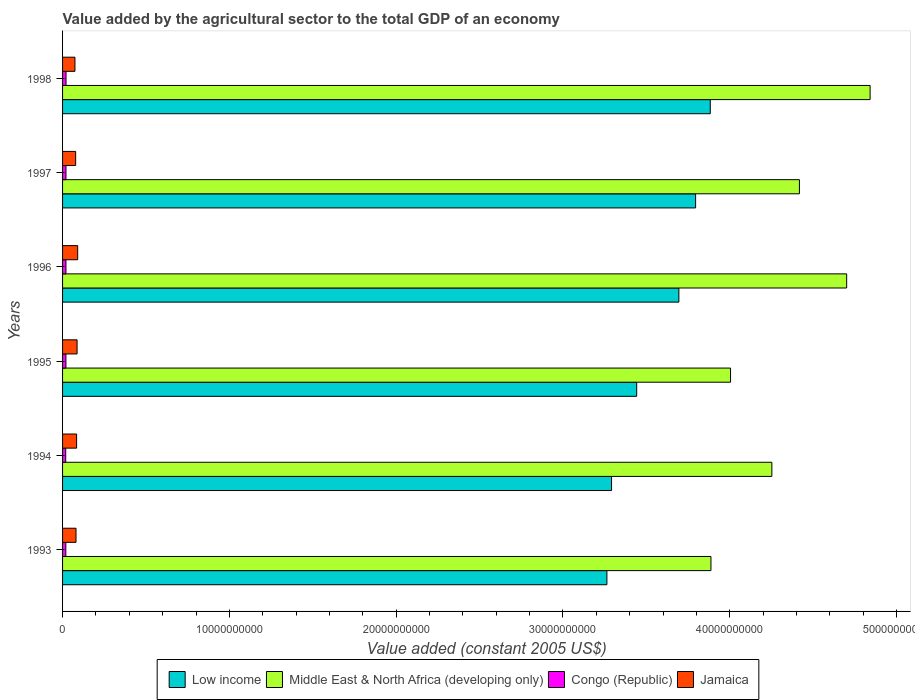How many groups of bars are there?
Ensure brevity in your answer.  6. How many bars are there on the 6th tick from the top?
Ensure brevity in your answer.  4. How many bars are there on the 4th tick from the bottom?
Make the answer very short. 4. What is the label of the 4th group of bars from the top?
Give a very brief answer. 1995. In how many cases, is the number of bars for a given year not equal to the number of legend labels?
Your response must be concise. 0. What is the value added by the agricultural sector in Low income in 1998?
Offer a terse response. 3.88e+1. Across all years, what is the maximum value added by the agricultural sector in Low income?
Provide a succinct answer. 3.88e+1. Across all years, what is the minimum value added by the agricultural sector in Jamaica?
Offer a very short reply. 7.42e+08. In which year was the value added by the agricultural sector in Middle East & North Africa (developing only) minimum?
Keep it short and to the point. 1993. What is the total value added by the agricultural sector in Congo (Republic) in the graph?
Provide a short and direct response. 1.20e+09. What is the difference between the value added by the agricultural sector in Jamaica in 1993 and that in 1994?
Offer a very short reply. -3.60e+07. What is the difference between the value added by the agricultural sector in Low income in 1998 and the value added by the agricultural sector in Congo (Republic) in 1997?
Keep it short and to the point. 3.86e+1. What is the average value added by the agricultural sector in Middle East & North Africa (developing only) per year?
Keep it short and to the point. 4.35e+1. In the year 1996, what is the difference between the value added by the agricultural sector in Low income and value added by the agricultural sector in Jamaica?
Your answer should be very brief. 3.60e+1. What is the ratio of the value added by the agricultural sector in Low income in 1997 to that in 1998?
Offer a very short reply. 0.98. Is the value added by the agricultural sector in Congo (Republic) in 1994 less than that in 1995?
Provide a short and direct response. Yes. Is the difference between the value added by the agricultural sector in Low income in 1993 and 1995 greater than the difference between the value added by the agricultural sector in Jamaica in 1993 and 1995?
Your response must be concise. No. What is the difference between the highest and the second highest value added by the agricultural sector in Congo (Republic)?
Give a very brief answer. 3.44e+06. What is the difference between the highest and the lowest value added by the agricultural sector in Middle East & North Africa (developing only)?
Provide a succinct answer. 9.54e+09. Is it the case that in every year, the sum of the value added by the agricultural sector in Congo (Republic) and value added by the agricultural sector in Jamaica is greater than the sum of value added by the agricultural sector in Middle East & North Africa (developing only) and value added by the agricultural sector in Low income?
Ensure brevity in your answer.  No. What does the 2nd bar from the top in 1995 represents?
Your answer should be very brief. Congo (Republic). What does the 4th bar from the bottom in 1996 represents?
Your answer should be very brief. Jamaica. How many bars are there?
Your response must be concise. 24. Are all the bars in the graph horizontal?
Offer a terse response. Yes. Where does the legend appear in the graph?
Your answer should be very brief. Bottom center. How are the legend labels stacked?
Your answer should be compact. Horizontal. What is the title of the graph?
Your answer should be very brief. Value added by the agricultural sector to the total GDP of an economy. Does "Guyana" appear as one of the legend labels in the graph?
Your answer should be very brief. No. What is the label or title of the X-axis?
Provide a succinct answer. Value added (constant 2005 US$). What is the Value added (constant 2005 US$) in Low income in 1993?
Your response must be concise. 3.26e+1. What is the Value added (constant 2005 US$) of Middle East & North Africa (developing only) in 1993?
Ensure brevity in your answer.  3.89e+1. What is the Value added (constant 2005 US$) of Congo (Republic) in 1993?
Keep it short and to the point. 1.96e+08. What is the Value added (constant 2005 US$) in Jamaica in 1993?
Your answer should be compact. 8.06e+08. What is the Value added (constant 2005 US$) in Low income in 1994?
Ensure brevity in your answer.  3.29e+1. What is the Value added (constant 2005 US$) in Middle East & North Africa (developing only) in 1994?
Your answer should be compact. 4.25e+1. What is the Value added (constant 2005 US$) of Congo (Republic) in 1994?
Your answer should be compact. 1.89e+08. What is the Value added (constant 2005 US$) in Jamaica in 1994?
Offer a very short reply. 8.42e+08. What is the Value added (constant 2005 US$) of Low income in 1995?
Make the answer very short. 3.44e+1. What is the Value added (constant 2005 US$) in Middle East & North Africa (developing only) in 1995?
Provide a short and direct response. 4.00e+1. What is the Value added (constant 2005 US$) in Congo (Republic) in 1995?
Keep it short and to the point. 2.02e+08. What is the Value added (constant 2005 US$) of Jamaica in 1995?
Your answer should be very brief. 8.70e+08. What is the Value added (constant 2005 US$) of Low income in 1996?
Give a very brief answer. 3.70e+1. What is the Value added (constant 2005 US$) in Middle East & North Africa (developing only) in 1996?
Give a very brief answer. 4.70e+1. What is the Value added (constant 2005 US$) in Congo (Republic) in 1996?
Ensure brevity in your answer.  2.03e+08. What is the Value added (constant 2005 US$) of Jamaica in 1996?
Make the answer very short. 9.05e+08. What is the Value added (constant 2005 US$) in Low income in 1997?
Make the answer very short. 3.80e+1. What is the Value added (constant 2005 US$) of Middle East & North Africa (developing only) in 1997?
Give a very brief answer. 4.42e+1. What is the Value added (constant 2005 US$) of Congo (Republic) in 1997?
Offer a terse response. 2.04e+08. What is the Value added (constant 2005 US$) of Jamaica in 1997?
Your response must be concise. 7.84e+08. What is the Value added (constant 2005 US$) in Low income in 1998?
Make the answer very short. 3.88e+1. What is the Value added (constant 2005 US$) in Middle East & North Africa (developing only) in 1998?
Your response must be concise. 4.84e+1. What is the Value added (constant 2005 US$) of Congo (Republic) in 1998?
Make the answer very short. 2.08e+08. What is the Value added (constant 2005 US$) in Jamaica in 1998?
Provide a succinct answer. 7.42e+08. Across all years, what is the maximum Value added (constant 2005 US$) of Low income?
Make the answer very short. 3.88e+1. Across all years, what is the maximum Value added (constant 2005 US$) in Middle East & North Africa (developing only)?
Your answer should be compact. 4.84e+1. Across all years, what is the maximum Value added (constant 2005 US$) in Congo (Republic)?
Ensure brevity in your answer.  2.08e+08. Across all years, what is the maximum Value added (constant 2005 US$) in Jamaica?
Provide a succinct answer. 9.05e+08. Across all years, what is the minimum Value added (constant 2005 US$) of Low income?
Your response must be concise. 3.26e+1. Across all years, what is the minimum Value added (constant 2005 US$) of Middle East & North Africa (developing only)?
Your response must be concise. 3.89e+1. Across all years, what is the minimum Value added (constant 2005 US$) of Congo (Republic)?
Ensure brevity in your answer.  1.89e+08. Across all years, what is the minimum Value added (constant 2005 US$) in Jamaica?
Give a very brief answer. 7.42e+08. What is the total Value added (constant 2005 US$) in Low income in the graph?
Your answer should be compact. 2.14e+11. What is the total Value added (constant 2005 US$) of Middle East & North Africa (developing only) in the graph?
Your response must be concise. 2.61e+11. What is the total Value added (constant 2005 US$) of Congo (Republic) in the graph?
Offer a terse response. 1.20e+09. What is the total Value added (constant 2005 US$) of Jamaica in the graph?
Your response must be concise. 4.95e+09. What is the difference between the Value added (constant 2005 US$) of Low income in 1993 and that in 1994?
Offer a terse response. -2.78e+08. What is the difference between the Value added (constant 2005 US$) of Middle East & North Africa (developing only) in 1993 and that in 1994?
Provide a short and direct response. -3.65e+09. What is the difference between the Value added (constant 2005 US$) in Congo (Republic) in 1993 and that in 1994?
Keep it short and to the point. 6.23e+06. What is the difference between the Value added (constant 2005 US$) in Jamaica in 1993 and that in 1994?
Give a very brief answer. -3.60e+07. What is the difference between the Value added (constant 2005 US$) in Low income in 1993 and that in 1995?
Your answer should be compact. -1.79e+09. What is the difference between the Value added (constant 2005 US$) in Middle East & North Africa (developing only) in 1993 and that in 1995?
Give a very brief answer. -1.17e+09. What is the difference between the Value added (constant 2005 US$) in Congo (Republic) in 1993 and that in 1995?
Offer a very short reply. -6.02e+06. What is the difference between the Value added (constant 2005 US$) in Jamaica in 1993 and that in 1995?
Offer a terse response. -6.43e+07. What is the difference between the Value added (constant 2005 US$) of Low income in 1993 and that in 1996?
Offer a very short reply. -4.31e+09. What is the difference between the Value added (constant 2005 US$) of Middle East & North Africa (developing only) in 1993 and that in 1996?
Give a very brief answer. -8.14e+09. What is the difference between the Value added (constant 2005 US$) of Congo (Republic) in 1993 and that in 1996?
Your answer should be very brief. -7.11e+06. What is the difference between the Value added (constant 2005 US$) in Jamaica in 1993 and that in 1996?
Offer a very short reply. -9.91e+07. What is the difference between the Value added (constant 2005 US$) of Low income in 1993 and that in 1997?
Offer a very short reply. -5.32e+09. What is the difference between the Value added (constant 2005 US$) of Middle East & North Africa (developing only) in 1993 and that in 1997?
Ensure brevity in your answer.  -5.30e+09. What is the difference between the Value added (constant 2005 US$) in Congo (Republic) in 1993 and that in 1997?
Your answer should be compact. -8.71e+06. What is the difference between the Value added (constant 2005 US$) in Jamaica in 1993 and that in 1997?
Ensure brevity in your answer.  2.17e+07. What is the difference between the Value added (constant 2005 US$) of Low income in 1993 and that in 1998?
Offer a very short reply. -6.20e+09. What is the difference between the Value added (constant 2005 US$) of Middle East & North Africa (developing only) in 1993 and that in 1998?
Your answer should be compact. -9.54e+09. What is the difference between the Value added (constant 2005 US$) in Congo (Republic) in 1993 and that in 1998?
Offer a very short reply. -1.22e+07. What is the difference between the Value added (constant 2005 US$) in Jamaica in 1993 and that in 1998?
Your answer should be compact. 6.37e+07. What is the difference between the Value added (constant 2005 US$) of Low income in 1994 and that in 1995?
Your answer should be very brief. -1.51e+09. What is the difference between the Value added (constant 2005 US$) of Middle East & North Africa (developing only) in 1994 and that in 1995?
Provide a succinct answer. 2.48e+09. What is the difference between the Value added (constant 2005 US$) of Congo (Republic) in 1994 and that in 1995?
Ensure brevity in your answer.  -1.23e+07. What is the difference between the Value added (constant 2005 US$) in Jamaica in 1994 and that in 1995?
Offer a very short reply. -2.83e+07. What is the difference between the Value added (constant 2005 US$) of Low income in 1994 and that in 1996?
Your response must be concise. -4.04e+09. What is the difference between the Value added (constant 2005 US$) of Middle East & North Africa (developing only) in 1994 and that in 1996?
Make the answer very short. -4.48e+09. What is the difference between the Value added (constant 2005 US$) in Congo (Republic) in 1994 and that in 1996?
Ensure brevity in your answer.  -1.33e+07. What is the difference between the Value added (constant 2005 US$) in Jamaica in 1994 and that in 1996?
Give a very brief answer. -6.31e+07. What is the difference between the Value added (constant 2005 US$) of Low income in 1994 and that in 1997?
Keep it short and to the point. -5.04e+09. What is the difference between the Value added (constant 2005 US$) of Middle East & North Africa (developing only) in 1994 and that in 1997?
Offer a terse response. -1.65e+09. What is the difference between the Value added (constant 2005 US$) in Congo (Republic) in 1994 and that in 1997?
Provide a succinct answer. -1.49e+07. What is the difference between the Value added (constant 2005 US$) in Jamaica in 1994 and that in 1997?
Provide a short and direct response. 5.77e+07. What is the difference between the Value added (constant 2005 US$) in Low income in 1994 and that in 1998?
Ensure brevity in your answer.  -5.92e+09. What is the difference between the Value added (constant 2005 US$) of Middle East & North Africa (developing only) in 1994 and that in 1998?
Offer a terse response. -5.89e+09. What is the difference between the Value added (constant 2005 US$) in Congo (Republic) in 1994 and that in 1998?
Give a very brief answer. -1.84e+07. What is the difference between the Value added (constant 2005 US$) of Jamaica in 1994 and that in 1998?
Provide a short and direct response. 9.97e+07. What is the difference between the Value added (constant 2005 US$) of Low income in 1995 and that in 1996?
Keep it short and to the point. -2.53e+09. What is the difference between the Value added (constant 2005 US$) of Middle East & North Africa (developing only) in 1995 and that in 1996?
Make the answer very short. -6.96e+09. What is the difference between the Value added (constant 2005 US$) in Congo (Republic) in 1995 and that in 1996?
Your response must be concise. -1.09e+06. What is the difference between the Value added (constant 2005 US$) in Jamaica in 1995 and that in 1996?
Give a very brief answer. -3.49e+07. What is the difference between the Value added (constant 2005 US$) in Low income in 1995 and that in 1997?
Offer a very short reply. -3.53e+09. What is the difference between the Value added (constant 2005 US$) in Middle East & North Africa (developing only) in 1995 and that in 1997?
Your answer should be very brief. -4.13e+09. What is the difference between the Value added (constant 2005 US$) of Congo (Republic) in 1995 and that in 1997?
Ensure brevity in your answer.  -2.69e+06. What is the difference between the Value added (constant 2005 US$) in Jamaica in 1995 and that in 1997?
Your response must be concise. 8.59e+07. What is the difference between the Value added (constant 2005 US$) of Low income in 1995 and that in 1998?
Your answer should be compact. -4.41e+09. What is the difference between the Value added (constant 2005 US$) of Middle East & North Africa (developing only) in 1995 and that in 1998?
Your answer should be compact. -8.37e+09. What is the difference between the Value added (constant 2005 US$) of Congo (Republic) in 1995 and that in 1998?
Ensure brevity in your answer.  -6.13e+06. What is the difference between the Value added (constant 2005 US$) in Jamaica in 1995 and that in 1998?
Keep it short and to the point. 1.28e+08. What is the difference between the Value added (constant 2005 US$) in Low income in 1996 and that in 1997?
Keep it short and to the point. -1.00e+09. What is the difference between the Value added (constant 2005 US$) in Middle East & North Africa (developing only) in 1996 and that in 1997?
Your answer should be very brief. 2.83e+09. What is the difference between the Value added (constant 2005 US$) in Congo (Republic) in 1996 and that in 1997?
Your answer should be compact. -1.60e+06. What is the difference between the Value added (constant 2005 US$) in Jamaica in 1996 and that in 1997?
Provide a succinct answer. 1.21e+08. What is the difference between the Value added (constant 2005 US$) of Low income in 1996 and that in 1998?
Provide a succinct answer. -1.88e+09. What is the difference between the Value added (constant 2005 US$) in Middle East & North Africa (developing only) in 1996 and that in 1998?
Make the answer very short. -1.41e+09. What is the difference between the Value added (constant 2005 US$) of Congo (Republic) in 1996 and that in 1998?
Provide a short and direct response. -5.04e+06. What is the difference between the Value added (constant 2005 US$) in Jamaica in 1996 and that in 1998?
Offer a terse response. 1.63e+08. What is the difference between the Value added (constant 2005 US$) in Low income in 1997 and that in 1998?
Your answer should be compact. -8.79e+08. What is the difference between the Value added (constant 2005 US$) of Middle East & North Africa (developing only) in 1997 and that in 1998?
Your answer should be compact. -4.24e+09. What is the difference between the Value added (constant 2005 US$) of Congo (Republic) in 1997 and that in 1998?
Ensure brevity in your answer.  -3.44e+06. What is the difference between the Value added (constant 2005 US$) in Jamaica in 1997 and that in 1998?
Offer a very short reply. 4.20e+07. What is the difference between the Value added (constant 2005 US$) in Low income in 1993 and the Value added (constant 2005 US$) in Middle East & North Africa (developing only) in 1994?
Give a very brief answer. -9.89e+09. What is the difference between the Value added (constant 2005 US$) in Low income in 1993 and the Value added (constant 2005 US$) in Congo (Republic) in 1994?
Offer a terse response. 3.24e+1. What is the difference between the Value added (constant 2005 US$) of Low income in 1993 and the Value added (constant 2005 US$) of Jamaica in 1994?
Offer a very short reply. 3.18e+1. What is the difference between the Value added (constant 2005 US$) in Middle East & North Africa (developing only) in 1993 and the Value added (constant 2005 US$) in Congo (Republic) in 1994?
Your answer should be very brief. 3.87e+1. What is the difference between the Value added (constant 2005 US$) in Middle East & North Africa (developing only) in 1993 and the Value added (constant 2005 US$) in Jamaica in 1994?
Offer a terse response. 3.80e+1. What is the difference between the Value added (constant 2005 US$) of Congo (Republic) in 1993 and the Value added (constant 2005 US$) of Jamaica in 1994?
Provide a succinct answer. -6.46e+08. What is the difference between the Value added (constant 2005 US$) in Low income in 1993 and the Value added (constant 2005 US$) in Middle East & North Africa (developing only) in 1995?
Offer a terse response. -7.41e+09. What is the difference between the Value added (constant 2005 US$) of Low income in 1993 and the Value added (constant 2005 US$) of Congo (Republic) in 1995?
Offer a very short reply. 3.24e+1. What is the difference between the Value added (constant 2005 US$) in Low income in 1993 and the Value added (constant 2005 US$) in Jamaica in 1995?
Provide a short and direct response. 3.18e+1. What is the difference between the Value added (constant 2005 US$) in Middle East & North Africa (developing only) in 1993 and the Value added (constant 2005 US$) in Congo (Republic) in 1995?
Provide a short and direct response. 3.87e+1. What is the difference between the Value added (constant 2005 US$) of Middle East & North Africa (developing only) in 1993 and the Value added (constant 2005 US$) of Jamaica in 1995?
Offer a very short reply. 3.80e+1. What is the difference between the Value added (constant 2005 US$) of Congo (Republic) in 1993 and the Value added (constant 2005 US$) of Jamaica in 1995?
Offer a very short reply. -6.75e+08. What is the difference between the Value added (constant 2005 US$) in Low income in 1993 and the Value added (constant 2005 US$) in Middle East & North Africa (developing only) in 1996?
Keep it short and to the point. -1.44e+1. What is the difference between the Value added (constant 2005 US$) in Low income in 1993 and the Value added (constant 2005 US$) in Congo (Republic) in 1996?
Offer a very short reply. 3.24e+1. What is the difference between the Value added (constant 2005 US$) in Low income in 1993 and the Value added (constant 2005 US$) in Jamaica in 1996?
Offer a terse response. 3.17e+1. What is the difference between the Value added (constant 2005 US$) of Middle East & North Africa (developing only) in 1993 and the Value added (constant 2005 US$) of Congo (Republic) in 1996?
Your answer should be compact. 3.87e+1. What is the difference between the Value added (constant 2005 US$) in Middle East & North Africa (developing only) in 1993 and the Value added (constant 2005 US$) in Jamaica in 1996?
Keep it short and to the point. 3.80e+1. What is the difference between the Value added (constant 2005 US$) of Congo (Republic) in 1993 and the Value added (constant 2005 US$) of Jamaica in 1996?
Make the answer very short. -7.10e+08. What is the difference between the Value added (constant 2005 US$) of Low income in 1993 and the Value added (constant 2005 US$) of Middle East & North Africa (developing only) in 1997?
Offer a very short reply. -1.15e+1. What is the difference between the Value added (constant 2005 US$) in Low income in 1993 and the Value added (constant 2005 US$) in Congo (Republic) in 1997?
Offer a terse response. 3.24e+1. What is the difference between the Value added (constant 2005 US$) of Low income in 1993 and the Value added (constant 2005 US$) of Jamaica in 1997?
Give a very brief answer. 3.19e+1. What is the difference between the Value added (constant 2005 US$) in Middle East & North Africa (developing only) in 1993 and the Value added (constant 2005 US$) in Congo (Republic) in 1997?
Ensure brevity in your answer.  3.87e+1. What is the difference between the Value added (constant 2005 US$) in Middle East & North Africa (developing only) in 1993 and the Value added (constant 2005 US$) in Jamaica in 1997?
Your response must be concise. 3.81e+1. What is the difference between the Value added (constant 2005 US$) in Congo (Republic) in 1993 and the Value added (constant 2005 US$) in Jamaica in 1997?
Your answer should be compact. -5.89e+08. What is the difference between the Value added (constant 2005 US$) of Low income in 1993 and the Value added (constant 2005 US$) of Middle East & North Africa (developing only) in 1998?
Offer a very short reply. -1.58e+1. What is the difference between the Value added (constant 2005 US$) in Low income in 1993 and the Value added (constant 2005 US$) in Congo (Republic) in 1998?
Keep it short and to the point. 3.24e+1. What is the difference between the Value added (constant 2005 US$) of Low income in 1993 and the Value added (constant 2005 US$) of Jamaica in 1998?
Your answer should be compact. 3.19e+1. What is the difference between the Value added (constant 2005 US$) in Middle East & North Africa (developing only) in 1993 and the Value added (constant 2005 US$) in Congo (Republic) in 1998?
Your answer should be compact. 3.87e+1. What is the difference between the Value added (constant 2005 US$) in Middle East & North Africa (developing only) in 1993 and the Value added (constant 2005 US$) in Jamaica in 1998?
Give a very brief answer. 3.81e+1. What is the difference between the Value added (constant 2005 US$) in Congo (Republic) in 1993 and the Value added (constant 2005 US$) in Jamaica in 1998?
Ensure brevity in your answer.  -5.47e+08. What is the difference between the Value added (constant 2005 US$) in Low income in 1994 and the Value added (constant 2005 US$) in Middle East & North Africa (developing only) in 1995?
Offer a terse response. -7.13e+09. What is the difference between the Value added (constant 2005 US$) of Low income in 1994 and the Value added (constant 2005 US$) of Congo (Republic) in 1995?
Provide a succinct answer. 3.27e+1. What is the difference between the Value added (constant 2005 US$) in Low income in 1994 and the Value added (constant 2005 US$) in Jamaica in 1995?
Keep it short and to the point. 3.20e+1. What is the difference between the Value added (constant 2005 US$) in Middle East & North Africa (developing only) in 1994 and the Value added (constant 2005 US$) in Congo (Republic) in 1995?
Give a very brief answer. 4.23e+1. What is the difference between the Value added (constant 2005 US$) in Middle East & North Africa (developing only) in 1994 and the Value added (constant 2005 US$) in Jamaica in 1995?
Make the answer very short. 4.17e+1. What is the difference between the Value added (constant 2005 US$) in Congo (Republic) in 1994 and the Value added (constant 2005 US$) in Jamaica in 1995?
Offer a terse response. -6.81e+08. What is the difference between the Value added (constant 2005 US$) of Low income in 1994 and the Value added (constant 2005 US$) of Middle East & North Africa (developing only) in 1996?
Provide a short and direct response. -1.41e+1. What is the difference between the Value added (constant 2005 US$) in Low income in 1994 and the Value added (constant 2005 US$) in Congo (Republic) in 1996?
Offer a very short reply. 3.27e+1. What is the difference between the Value added (constant 2005 US$) in Low income in 1994 and the Value added (constant 2005 US$) in Jamaica in 1996?
Keep it short and to the point. 3.20e+1. What is the difference between the Value added (constant 2005 US$) in Middle East & North Africa (developing only) in 1994 and the Value added (constant 2005 US$) in Congo (Republic) in 1996?
Ensure brevity in your answer.  4.23e+1. What is the difference between the Value added (constant 2005 US$) in Middle East & North Africa (developing only) in 1994 and the Value added (constant 2005 US$) in Jamaica in 1996?
Your answer should be very brief. 4.16e+1. What is the difference between the Value added (constant 2005 US$) of Congo (Republic) in 1994 and the Value added (constant 2005 US$) of Jamaica in 1996?
Provide a succinct answer. -7.16e+08. What is the difference between the Value added (constant 2005 US$) of Low income in 1994 and the Value added (constant 2005 US$) of Middle East & North Africa (developing only) in 1997?
Make the answer very short. -1.13e+1. What is the difference between the Value added (constant 2005 US$) of Low income in 1994 and the Value added (constant 2005 US$) of Congo (Republic) in 1997?
Offer a terse response. 3.27e+1. What is the difference between the Value added (constant 2005 US$) in Low income in 1994 and the Value added (constant 2005 US$) in Jamaica in 1997?
Your answer should be compact. 3.21e+1. What is the difference between the Value added (constant 2005 US$) of Middle East & North Africa (developing only) in 1994 and the Value added (constant 2005 US$) of Congo (Republic) in 1997?
Make the answer very short. 4.23e+1. What is the difference between the Value added (constant 2005 US$) of Middle East & North Africa (developing only) in 1994 and the Value added (constant 2005 US$) of Jamaica in 1997?
Provide a short and direct response. 4.17e+1. What is the difference between the Value added (constant 2005 US$) of Congo (Republic) in 1994 and the Value added (constant 2005 US$) of Jamaica in 1997?
Your answer should be compact. -5.95e+08. What is the difference between the Value added (constant 2005 US$) of Low income in 1994 and the Value added (constant 2005 US$) of Middle East & North Africa (developing only) in 1998?
Your answer should be compact. -1.55e+1. What is the difference between the Value added (constant 2005 US$) of Low income in 1994 and the Value added (constant 2005 US$) of Congo (Republic) in 1998?
Your response must be concise. 3.27e+1. What is the difference between the Value added (constant 2005 US$) in Low income in 1994 and the Value added (constant 2005 US$) in Jamaica in 1998?
Provide a short and direct response. 3.22e+1. What is the difference between the Value added (constant 2005 US$) in Middle East & North Africa (developing only) in 1994 and the Value added (constant 2005 US$) in Congo (Republic) in 1998?
Keep it short and to the point. 4.23e+1. What is the difference between the Value added (constant 2005 US$) in Middle East & North Africa (developing only) in 1994 and the Value added (constant 2005 US$) in Jamaica in 1998?
Your answer should be very brief. 4.18e+1. What is the difference between the Value added (constant 2005 US$) of Congo (Republic) in 1994 and the Value added (constant 2005 US$) of Jamaica in 1998?
Provide a short and direct response. -5.53e+08. What is the difference between the Value added (constant 2005 US$) in Low income in 1995 and the Value added (constant 2005 US$) in Middle East & North Africa (developing only) in 1996?
Make the answer very short. -1.26e+1. What is the difference between the Value added (constant 2005 US$) of Low income in 1995 and the Value added (constant 2005 US$) of Congo (Republic) in 1996?
Your response must be concise. 3.42e+1. What is the difference between the Value added (constant 2005 US$) in Low income in 1995 and the Value added (constant 2005 US$) in Jamaica in 1996?
Make the answer very short. 3.35e+1. What is the difference between the Value added (constant 2005 US$) of Middle East & North Africa (developing only) in 1995 and the Value added (constant 2005 US$) of Congo (Republic) in 1996?
Provide a succinct answer. 3.98e+1. What is the difference between the Value added (constant 2005 US$) of Middle East & North Africa (developing only) in 1995 and the Value added (constant 2005 US$) of Jamaica in 1996?
Make the answer very short. 3.91e+1. What is the difference between the Value added (constant 2005 US$) in Congo (Republic) in 1995 and the Value added (constant 2005 US$) in Jamaica in 1996?
Your response must be concise. -7.04e+08. What is the difference between the Value added (constant 2005 US$) of Low income in 1995 and the Value added (constant 2005 US$) of Middle East & North Africa (developing only) in 1997?
Provide a short and direct response. -9.76e+09. What is the difference between the Value added (constant 2005 US$) of Low income in 1995 and the Value added (constant 2005 US$) of Congo (Republic) in 1997?
Your response must be concise. 3.42e+1. What is the difference between the Value added (constant 2005 US$) in Low income in 1995 and the Value added (constant 2005 US$) in Jamaica in 1997?
Make the answer very short. 3.36e+1. What is the difference between the Value added (constant 2005 US$) of Middle East & North Africa (developing only) in 1995 and the Value added (constant 2005 US$) of Congo (Republic) in 1997?
Provide a succinct answer. 3.98e+1. What is the difference between the Value added (constant 2005 US$) of Middle East & North Africa (developing only) in 1995 and the Value added (constant 2005 US$) of Jamaica in 1997?
Offer a terse response. 3.93e+1. What is the difference between the Value added (constant 2005 US$) in Congo (Republic) in 1995 and the Value added (constant 2005 US$) in Jamaica in 1997?
Ensure brevity in your answer.  -5.83e+08. What is the difference between the Value added (constant 2005 US$) in Low income in 1995 and the Value added (constant 2005 US$) in Middle East & North Africa (developing only) in 1998?
Keep it short and to the point. -1.40e+1. What is the difference between the Value added (constant 2005 US$) in Low income in 1995 and the Value added (constant 2005 US$) in Congo (Republic) in 1998?
Offer a terse response. 3.42e+1. What is the difference between the Value added (constant 2005 US$) of Low income in 1995 and the Value added (constant 2005 US$) of Jamaica in 1998?
Keep it short and to the point. 3.37e+1. What is the difference between the Value added (constant 2005 US$) in Middle East & North Africa (developing only) in 1995 and the Value added (constant 2005 US$) in Congo (Republic) in 1998?
Your answer should be compact. 3.98e+1. What is the difference between the Value added (constant 2005 US$) in Middle East & North Africa (developing only) in 1995 and the Value added (constant 2005 US$) in Jamaica in 1998?
Provide a succinct answer. 3.93e+1. What is the difference between the Value added (constant 2005 US$) of Congo (Republic) in 1995 and the Value added (constant 2005 US$) of Jamaica in 1998?
Your answer should be very brief. -5.41e+08. What is the difference between the Value added (constant 2005 US$) in Low income in 1996 and the Value added (constant 2005 US$) in Middle East & North Africa (developing only) in 1997?
Provide a short and direct response. -7.23e+09. What is the difference between the Value added (constant 2005 US$) of Low income in 1996 and the Value added (constant 2005 US$) of Congo (Republic) in 1997?
Provide a short and direct response. 3.67e+1. What is the difference between the Value added (constant 2005 US$) in Low income in 1996 and the Value added (constant 2005 US$) in Jamaica in 1997?
Offer a very short reply. 3.62e+1. What is the difference between the Value added (constant 2005 US$) in Middle East & North Africa (developing only) in 1996 and the Value added (constant 2005 US$) in Congo (Republic) in 1997?
Ensure brevity in your answer.  4.68e+1. What is the difference between the Value added (constant 2005 US$) of Middle East & North Africa (developing only) in 1996 and the Value added (constant 2005 US$) of Jamaica in 1997?
Ensure brevity in your answer.  4.62e+1. What is the difference between the Value added (constant 2005 US$) of Congo (Republic) in 1996 and the Value added (constant 2005 US$) of Jamaica in 1997?
Your answer should be compact. -5.82e+08. What is the difference between the Value added (constant 2005 US$) of Low income in 1996 and the Value added (constant 2005 US$) of Middle East & North Africa (developing only) in 1998?
Offer a terse response. -1.15e+1. What is the difference between the Value added (constant 2005 US$) in Low income in 1996 and the Value added (constant 2005 US$) in Congo (Republic) in 1998?
Ensure brevity in your answer.  3.67e+1. What is the difference between the Value added (constant 2005 US$) in Low income in 1996 and the Value added (constant 2005 US$) in Jamaica in 1998?
Your answer should be very brief. 3.62e+1. What is the difference between the Value added (constant 2005 US$) of Middle East & North Africa (developing only) in 1996 and the Value added (constant 2005 US$) of Congo (Republic) in 1998?
Make the answer very short. 4.68e+1. What is the difference between the Value added (constant 2005 US$) of Middle East & North Africa (developing only) in 1996 and the Value added (constant 2005 US$) of Jamaica in 1998?
Give a very brief answer. 4.63e+1. What is the difference between the Value added (constant 2005 US$) in Congo (Republic) in 1996 and the Value added (constant 2005 US$) in Jamaica in 1998?
Provide a succinct answer. -5.40e+08. What is the difference between the Value added (constant 2005 US$) in Low income in 1997 and the Value added (constant 2005 US$) in Middle East & North Africa (developing only) in 1998?
Provide a short and direct response. -1.05e+1. What is the difference between the Value added (constant 2005 US$) of Low income in 1997 and the Value added (constant 2005 US$) of Congo (Republic) in 1998?
Make the answer very short. 3.77e+1. What is the difference between the Value added (constant 2005 US$) in Low income in 1997 and the Value added (constant 2005 US$) in Jamaica in 1998?
Provide a short and direct response. 3.72e+1. What is the difference between the Value added (constant 2005 US$) in Middle East & North Africa (developing only) in 1997 and the Value added (constant 2005 US$) in Congo (Republic) in 1998?
Ensure brevity in your answer.  4.40e+1. What is the difference between the Value added (constant 2005 US$) of Middle East & North Africa (developing only) in 1997 and the Value added (constant 2005 US$) of Jamaica in 1998?
Your response must be concise. 4.34e+1. What is the difference between the Value added (constant 2005 US$) in Congo (Republic) in 1997 and the Value added (constant 2005 US$) in Jamaica in 1998?
Offer a very short reply. -5.38e+08. What is the average Value added (constant 2005 US$) in Low income per year?
Keep it short and to the point. 3.56e+1. What is the average Value added (constant 2005 US$) in Middle East & North Africa (developing only) per year?
Offer a very short reply. 4.35e+1. What is the average Value added (constant 2005 US$) of Congo (Republic) per year?
Offer a very short reply. 2.00e+08. What is the average Value added (constant 2005 US$) in Jamaica per year?
Your answer should be compact. 8.25e+08. In the year 1993, what is the difference between the Value added (constant 2005 US$) of Low income and Value added (constant 2005 US$) of Middle East & North Africa (developing only)?
Ensure brevity in your answer.  -6.24e+09. In the year 1993, what is the difference between the Value added (constant 2005 US$) of Low income and Value added (constant 2005 US$) of Congo (Republic)?
Offer a terse response. 3.24e+1. In the year 1993, what is the difference between the Value added (constant 2005 US$) in Low income and Value added (constant 2005 US$) in Jamaica?
Your answer should be very brief. 3.18e+1. In the year 1993, what is the difference between the Value added (constant 2005 US$) of Middle East & North Africa (developing only) and Value added (constant 2005 US$) of Congo (Republic)?
Provide a succinct answer. 3.87e+1. In the year 1993, what is the difference between the Value added (constant 2005 US$) of Middle East & North Africa (developing only) and Value added (constant 2005 US$) of Jamaica?
Offer a terse response. 3.81e+1. In the year 1993, what is the difference between the Value added (constant 2005 US$) in Congo (Republic) and Value added (constant 2005 US$) in Jamaica?
Ensure brevity in your answer.  -6.10e+08. In the year 1994, what is the difference between the Value added (constant 2005 US$) of Low income and Value added (constant 2005 US$) of Middle East & North Africa (developing only)?
Make the answer very short. -9.61e+09. In the year 1994, what is the difference between the Value added (constant 2005 US$) in Low income and Value added (constant 2005 US$) in Congo (Republic)?
Keep it short and to the point. 3.27e+1. In the year 1994, what is the difference between the Value added (constant 2005 US$) of Low income and Value added (constant 2005 US$) of Jamaica?
Give a very brief answer. 3.21e+1. In the year 1994, what is the difference between the Value added (constant 2005 US$) in Middle East & North Africa (developing only) and Value added (constant 2005 US$) in Congo (Republic)?
Offer a terse response. 4.23e+1. In the year 1994, what is the difference between the Value added (constant 2005 US$) in Middle East & North Africa (developing only) and Value added (constant 2005 US$) in Jamaica?
Ensure brevity in your answer.  4.17e+1. In the year 1994, what is the difference between the Value added (constant 2005 US$) of Congo (Republic) and Value added (constant 2005 US$) of Jamaica?
Offer a terse response. -6.53e+08. In the year 1995, what is the difference between the Value added (constant 2005 US$) of Low income and Value added (constant 2005 US$) of Middle East & North Africa (developing only)?
Give a very brief answer. -5.63e+09. In the year 1995, what is the difference between the Value added (constant 2005 US$) of Low income and Value added (constant 2005 US$) of Congo (Republic)?
Provide a succinct answer. 3.42e+1. In the year 1995, what is the difference between the Value added (constant 2005 US$) in Low income and Value added (constant 2005 US$) in Jamaica?
Provide a short and direct response. 3.36e+1. In the year 1995, what is the difference between the Value added (constant 2005 US$) of Middle East & North Africa (developing only) and Value added (constant 2005 US$) of Congo (Republic)?
Offer a very short reply. 3.98e+1. In the year 1995, what is the difference between the Value added (constant 2005 US$) of Middle East & North Africa (developing only) and Value added (constant 2005 US$) of Jamaica?
Give a very brief answer. 3.92e+1. In the year 1995, what is the difference between the Value added (constant 2005 US$) of Congo (Republic) and Value added (constant 2005 US$) of Jamaica?
Keep it short and to the point. -6.69e+08. In the year 1996, what is the difference between the Value added (constant 2005 US$) of Low income and Value added (constant 2005 US$) of Middle East & North Africa (developing only)?
Give a very brief answer. -1.01e+1. In the year 1996, what is the difference between the Value added (constant 2005 US$) in Low income and Value added (constant 2005 US$) in Congo (Republic)?
Offer a very short reply. 3.67e+1. In the year 1996, what is the difference between the Value added (constant 2005 US$) in Low income and Value added (constant 2005 US$) in Jamaica?
Make the answer very short. 3.60e+1. In the year 1996, what is the difference between the Value added (constant 2005 US$) of Middle East & North Africa (developing only) and Value added (constant 2005 US$) of Congo (Republic)?
Your response must be concise. 4.68e+1. In the year 1996, what is the difference between the Value added (constant 2005 US$) of Middle East & North Africa (developing only) and Value added (constant 2005 US$) of Jamaica?
Provide a succinct answer. 4.61e+1. In the year 1996, what is the difference between the Value added (constant 2005 US$) in Congo (Republic) and Value added (constant 2005 US$) in Jamaica?
Offer a very short reply. -7.02e+08. In the year 1997, what is the difference between the Value added (constant 2005 US$) of Low income and Value added (constant 2005 US$) of Middle East & North Africa (developing only)?
Offer a terse response. -6.22e+09. In the year 1997, what is the difference between the Value added (constant 2005 US$) of Low income and Value added (constant 2005 US$) of Congo (Republic)?
Ensure brevity in your answer.  3.78e+1. In the year 1997, what is the difference between the Value added (constant 2005 US$) in Low income and Value added (constant 2005 US$) in Jamaica?
Give a very brief answer. 3.72e+1. In the year 1997, what is the difference between the Value added (constant 2005 US$) of Middle East & North Africa (developing only) and Value added (constant 2005 US$) of Congo (Republic)?
Offer a very short reply. 4.40e+1. In the year 1997, what is the difference between the Value added (constant 2005 US$) of Middle East & North Africa (developing only) and Value added (constant 2005 US$) of Jamaica?
Your answer should be compact. 4.34e+1. In the year 1997, what is the difference between the Value added (constant 2005 US$) in Congo (Republic) and Value added (constant 2005 US$) in Jamaica?
Keep it short and to the point. -5.80e+08. In the year 1998, what is the difference between the Value added (constant 2005 US$) of Low income and Value added (constant 2005 US$) of Middle East & North Africa (developing only)?
Your response must be concise. -9.58e+09. In the year 1998, what is the difference between the Value added (constant 2005 US$) of Low income and Value added (constant 2005 US$) of Congo (Republic)?
Keep it short and to the point. 3.86e+1. In the year 1998, what is the difference between the Value added (constant 2005 US$) in Low income and Value added (constant 2005 US$) in Jamaica?
Make the answer very short. 3.81e+1. In the year 1998, what is the difference between the Value added (constant 2005 US$) in Middle East & North Africa (developing only) and Value added (constant 2005 US$) in Congo (Republic)?
Provide a succinct answer. 4.82e+1. In the year 1998, what is the difference between the Value added (constant 2005 US$) in Middle East & North Africa (developing only) and Value added (constant 2005 US$) in Jamaica?
Keep it short and to the point. 4.77e+1. In the year 1998, what is the difference between the Value added (constant 2005 US$) of Congo (Republic) and Value added (constant 2005 US$) of Jamaica?
Ensure brevity in your answer.  -5.35e+08. What is the ratio of the Value added (constant 2005 US$) in Middle East & North Africa (developing only) in 1993 to that in 1994?
Your answer should be compact. 0.91. What is the ratio of the Value added (constant 2005 US$) of Congo (Republic) in 1993 to that in 1994?
Your answer should be very brief. 1.03. What is the ratio of the Value added (constant 2005 US$) in Jamaica in 1993 to that in 1994?
Your answer should be compact. 0.96. What is the ratio of the Value added (constant 2005 US$) of Low income in 1993 to that in 1995?
Offer a terse response. 0.95. What is the ratio of the Value added (constant 2005 US$) in Middle East & North Africa (developing only) in 1993 to that in 1995?
Make the answer very short. 0.97. What is the ratio of the Value added (constant 2005 US$) in Congo (Republic) in 1993 to that in 1995?
Your answer should be compact. 0.97. What is the ratio of the Value added (constant 2005 US$) in Jamaica in 1993 to that in 1995?
Ensure brevity in your answer.  0.93. What is the ratio of the Value added (constant 2005 US$) of Low income in 1993 to that in 1996?
Give a very brief answer. 0.88. What is the ratio of the Value added (constant 2005 US$) in Middle East & North Africa (developing only) in 1993 to that in 1996?
Make the answer very short. 0.83. What is the ratio of the Value added (constant 2005 US$) in Congo (Republic) in 1993 to that in 1996?
Offer a terse response. 0.96. What is the ratio of the Value added (constant 2005 US$) of Jamaica in 1993 to that in 1996?
Ensure brevity in your answer.  0.89. What is the ratio of the Value added (constant 2005 US$) of Low income in 1993 to that in 1997?
Offer a very short reply. 0.86. What is the ratio of the Value added (constant 2005 US$) of Middle East & North Africa (developing only) in 1993 to that in 1997?
Provide a short and direct response. 0.88. What is the ratio of the Value added (constant 2005 US$) of Congo (Republic) in 1993 to that in 1997?
Give a very brief answer. 0.96. What is the ratio of the Value added (constant 2005 US$) in Jamaica in 1993 to that in 1997?
Your answer should be compact. 1.03. What is the ratio of the Value added (constant 2005 US$) of Low income in 1993 to that in 1998?
Keep it short and to the point. 0.84. What is the ratio of the Value added (constant 2005 US$) of Middle East & North Africa (developing only) in 1993 to that in 1998?
Offer a terse response. 0.8. What is the ratio of the Value added (constant 2005 US$) of Congo (Republic) in 1993 to that in 1998?
Give a very brief answer. 0.94. What is the ratio of the Value added (constant 2005 US$) of Jamaica in 1993 to that in 1998?
Keep it short and to the point. 1.09. What is the ratio of the Value added (constant 2005 US$) of Low income in 1994 to that in 1995?
Keep it short and to the point. 0.96. What is the ratio of the Value added (constant 2005 US$) in Middle East & North Africa (developing only) in 1994 to that in 1995?
Your answer should be very brief. 1.06. What is the ratio of the Value added (constant 2005 US$) in Congo (Republic) in 1994 to that in 1995?
Provide a short and direct response. 0.94. What is the ratio of the Value added (constant 2005 US$) of Jamaica in 1994 to that in 1995?
Your response must be concise. 0.97. What is the ratio of the Value added (constant 2005 US$) in Low income in 1994 to that in 1996?
Provide a succinct answer. 0.89. What is the ratio of the Value added (constant 2005 US$) in Middle East & North Africa (developing only) in 1994 to that in 1996?
Your response must be concise. 0.9. What is the ratio of the Value added (constant 2005 US$) of Congo (Republic) in 1994 to that in 1996?
Offer a terse response. 0.93. What is the ratio of the Value added (constant 2005 US$) in Jamaica in 1994 to that in 1996?
Offer a very short reply. 0.93. What is the ratio of the Value added (constant 2005 US$) in Low income in 1994 to that in 1997?
Keep it short and to the point. 0.87. What is the ratio of the Value added (constant 2005 US$) in Middle East & North Africa (developing only) in 1994 to that in 1997?
Offer a very short reply. 0.96. What is the ratio of the Value added (constant 2005 US$) of Congo (Republic) in 1994 to that in 1997?
Offer a terse response. 0.93. What is the ratio of the Value added (constant 2005 US$) of Jamaica in 1994 to that in 1997?
Give a very brief answer. 1.07. What is the ratio of the Value added (constant 2005 US$) of Low income in 1994 to that in 1998?
Provide a short and direct response. 0.85. What is the ratio of the Value added (constant 2005 US$) in Middle East & North Africa (developing only) in 1994 to that in 1998?
Offer a very short reply. 0.88. What is the ratio of the Value added (constant 2005 US$) of Congo (Republic) in 1994 to that in 1998?
Provide a short and direct response. 0.91. What is the ratio of the Value added (constant 2005 US$) in Jamaica in 1994 to that in 1998?
Offer a very short reply. 1.13. What is the ratio of the Value added (constant 2005 US$) in Low income in 1995 to that in 1996?
Your response must be concise. 0.93. What is the ratio of the Value added (constant 2005 US$) of Middle East & North Africa (developing only) in 1995 to that in 1996?
Make the answer very short. 0.85. What is the ratio of the Value added (constant 2005 US$) of Congo (Republic) in 1995 to that in 1996?
Provide a succinct answer. 0.99. What is the ratio of the Value added (constant 2005 US$) in Jamaica in 1995 to that in 1996?
Your answer should be compact. 0.96. What is the ratio of the Value added (constant 2005 US$) of Low income in 1995 to that in 1997?
Offer a terse response. 0.91. What is the ratio of the Value added (constant 2005 US$) of Middle East & North Africa (developing only) in 1995 to that in 1997?
Ensure brevity in your answer.  0.91. What is the ratio of the Value added (constant 2005 US$) in Congo (Republic) in 1995 to that in 1997?
Ensure brevity in your answer.  0.99. What is the ratio of the Value added (constant 2005 US$) in Jamaica in 1995 to that in 1997?
Ensure brevity in your answer.  1.11. What is the ratio of the Value added (constant 2005 US$) in Low income in 1995 to that in 1998?
Give a very brief answer. 0.89. What is the ratio of the Value added (constant 2005 US$) of Middle East & North Africa (developing only) in 1995 to that in 1998?
Offer a very short reply. 0.83. What is the ratio of the Value added (constant 2005 US$) of Congo (Republic) in 1995 to that in 1998?
Keep it short and to the point. 0.97. What is the ratio of the Value added (constant 2005 US$) in Jamaica in 1995 to that in 1998?
Provide a short and direct response. 1.17. What is the ratio of the Value added (constant 2005 US$) of Low income in 1996 to that in 1997?
Ensure brevity in your answer.  0.97. What is the ratio of the Value added (constant 2005 US$) of Middle East & North Africa (developing only) in 1996 to that in 1997?
Ensure brevity in your answer.  1.06. What is the ratio of the Value added (constant 2005 US$) of Congo (Republic) in 1996 to that in 1997?
Ensure brevity in your answer.  0.99. What is the ratio of the Value added (constant 2005 US$) in Jamaica in 1996 to that in 1997?
Provide a short and direct response. 1.15. What is the ratio of the Value added (constant 2005 US$) of Low income in 1996 to that in 1998?
Make the answer very short. 0.95. What is the ratio of the Value added (constant 2005 US$) in Middle East & North Africa (developing only) in 1996 to that in 1998?
Your answer should be very brief. 0.97. What is the ratio of the Value added (constant 2005 US$) in Congo (Republic) in 1996 to that in 1998?
Provide a succinct answer. 0.98. What is the ratio of the Value added (constant 2005 US$) in Jamaica in 1996 to that in 1998?
Ensure brevity in your answer.  1.22. What is the ratio of the Value added (constant 2005 US$) in Low income in 1997 to that in 1998?
Make the answer very short. 0.98. What is the ratio of the Value added (constant 2005 US$) of Middle East & North Africa (developing only) in 1997 to that in 1998?
Your response must be concise. 0.91. What is the ratio of the Value added (constant 2005 US$) of Congo (Republic) in 1997 to that in 1998?
Provide a succinct answer. 0.98. What is the ratio of the Value added (constant 2005 US$) of Jamaica in 1997 to that in 1998?
Keep it short and to the point. 1.06. What is the difference between the highest and the second highest Value added (constant 2005 US$) in Low income?
Give a very brief answer. 8.79e+08. What is the difference between the highest and the second highest Value added (constant 2005 US$) in Middle East & North Africa (developing only)?
Provide a succinct answer. 1.41e+09. What is the difference between the highest and the second highest Value added (constant 2005 US$) in Congo (Republic)?
Ensure brevity in your answer.  3.44e+06. What is the difference between the highest and the second highest Value added (constant 2005 US$) in Jamaica?
Provide a succinct answer. 3.49e+07. What is the difference between the highest and the lowest Value added (constant 2005 US$) in Low income?
Make the answer very short. 6.20e+09. What is the difference between the highest and the lowest Value added (constant 2005 US$) in Middle East & North Africa (developing only)?
Offer a very short reply. 9.54e+09. What is the difference between the highest and the lowest Value added (constant 2005 US$) in Congo (Republic)?
Your answer should be compact. 1.84e+07. What is the difference between the highest and the lowest Value added (constant 2005 US$) in Jamaica?
Your answer should be compact. 1.63e+08. 